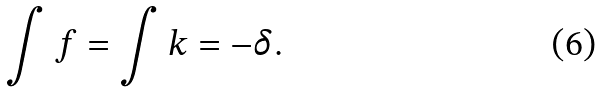Convert formula to latex. <formula><loc_0><loc_0><loc_500><loc_500>\int f = \int k = - \delta .</formula> 